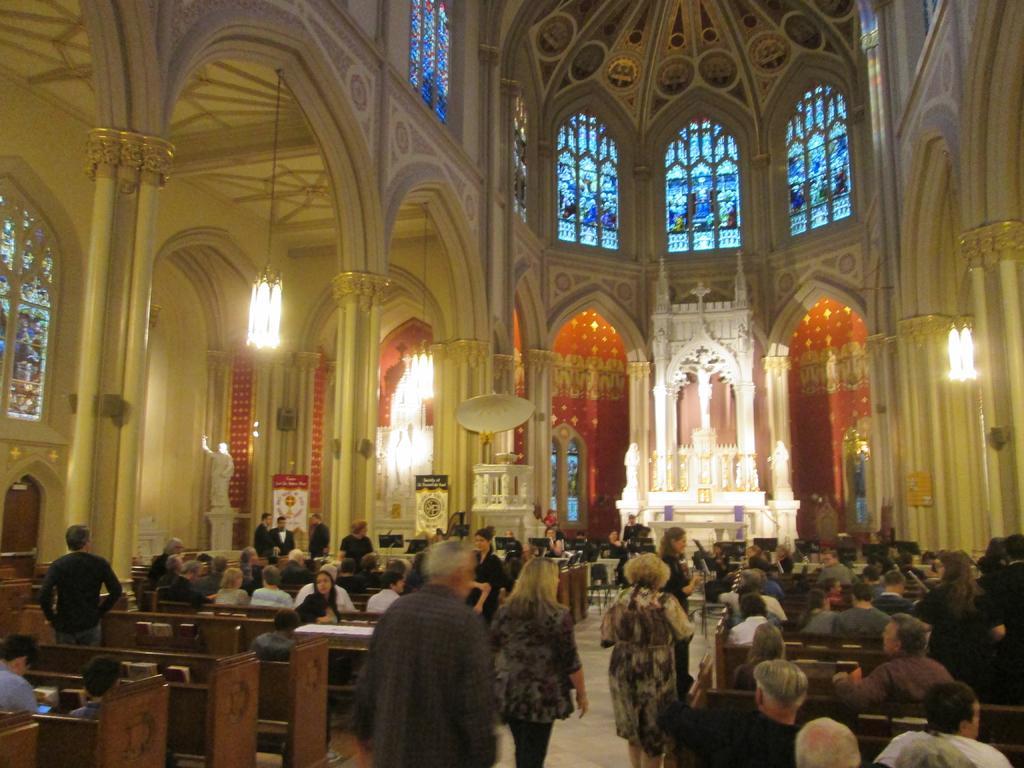How would you summarize this image in a sentence or two? In this image we can see a few people walking on the floor and a few people sitting on the benches. And we can see the wall with a design and pillars. There are windows, lights, statue and boards. 